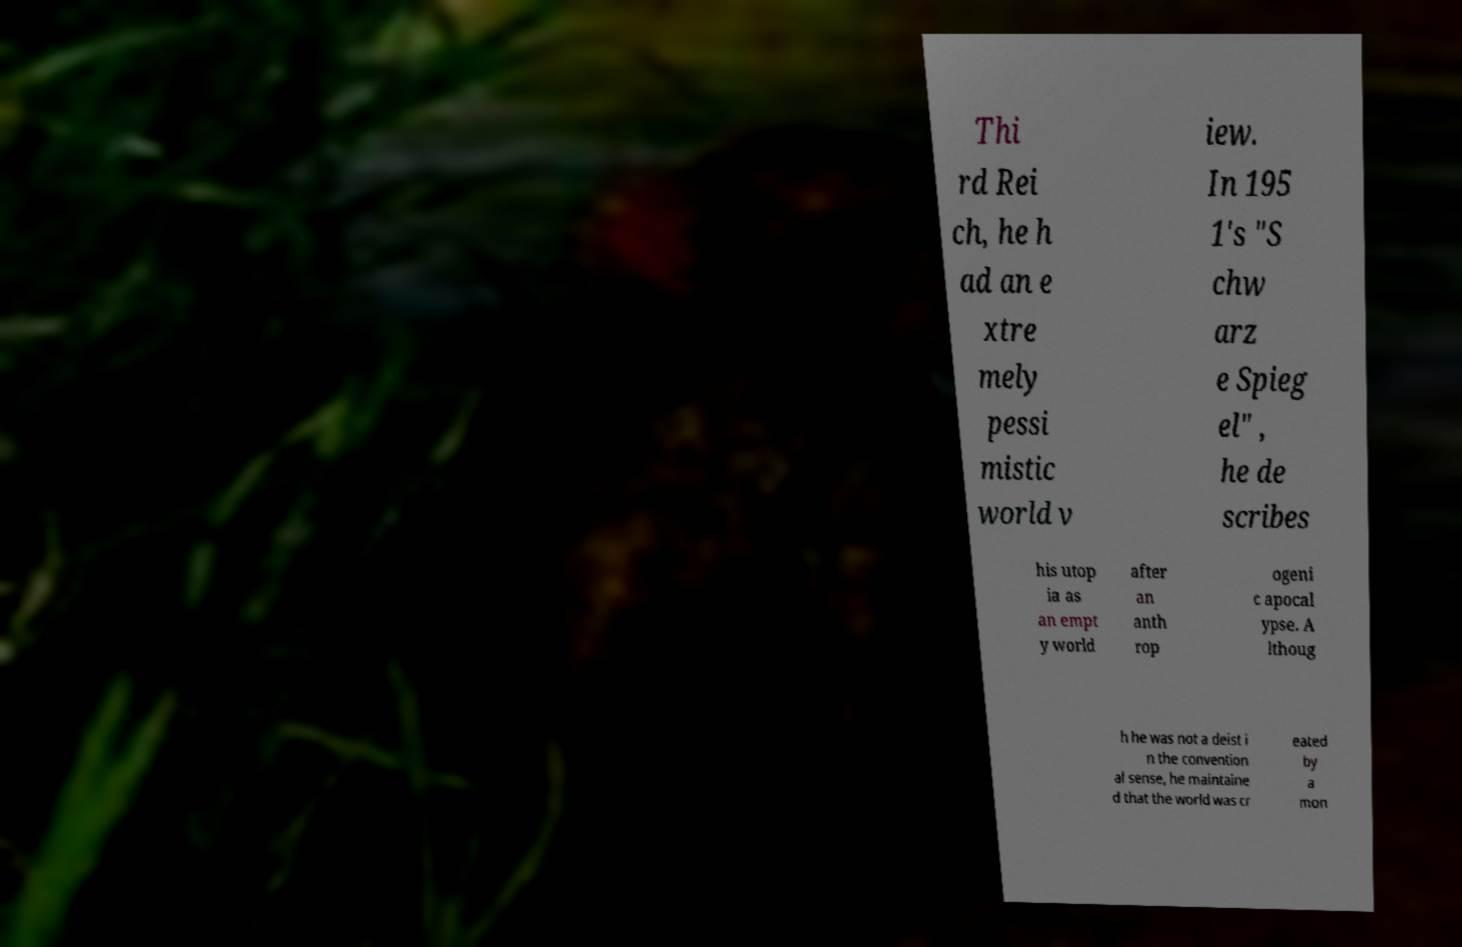Could you extract and type out the text from this image? Thi rd Rei ch, he h ad an e xtre mely pessi mistic world v iew. In 195 1's "S chw arz e Spieg el" , he de scribes his utop ia as an empt y world after an anth rop ogeni c apocal ypse. A lthoug h he was not a deist i n the convention al sense, he maintaine d that the world was cr eated by a mon 